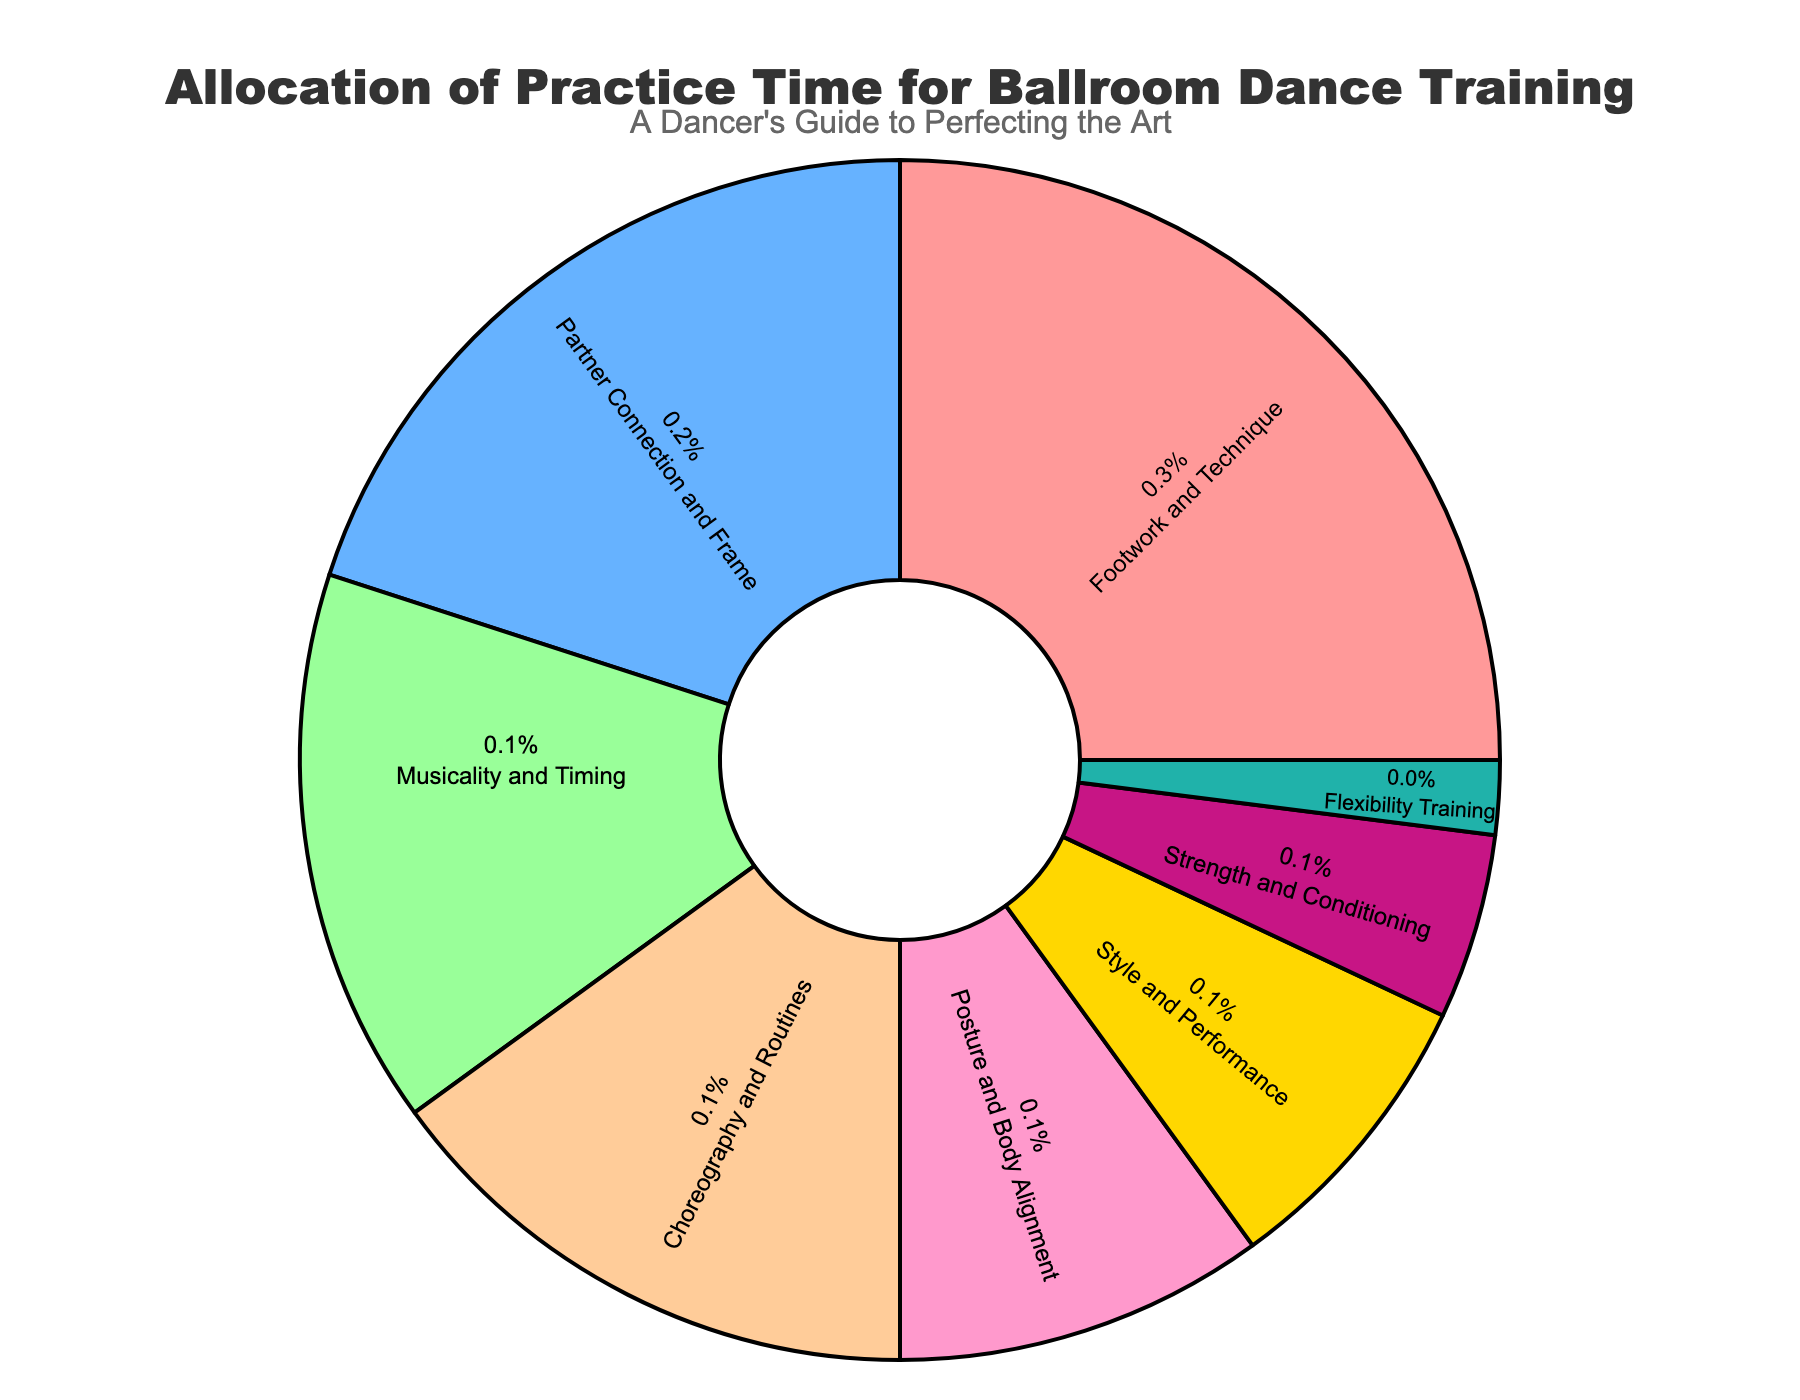what aspect of ballroom dance training takes up the largest percentage? The aspect with the largest percentage can be identified by looking at the slice with the biggest size in the pie chart, which is labeled with its percentage and aspect name. The largest slice is labeled "Footwork and Technique" with 25%.
Answer: Footwork and Technique Which aspects have an equal allocation of practice time? To find equal allocations, look for slices with the same percentage label. The aspects "Musicality and Timing" and "Choreography and Routines" both have a 15% allocation.
Answer: Musicality and Timing, Choreography and Routines How much more practice time is allocated to Footwork and Technique than to Flexibility Training? To find the difference, subtract the percentage allocated to Flexibility Training from Footwork and Technique: 25% - 2% = 23%.
Answer: 23% What is the combined allocation percentage for Partner Connection and Frame and Posture and Body Alignment? To find the combined allocation, sum the percentages for both aspects: 20% (Partner Connection and Frame) + 10% (Posture and Body Alignment) = 30%.
Answer: 30% Which aspect is allocated exactly half the percentage of Partner Connection and Frame? Half of the allocation for Partner Connection and Frame (20%) is 10%. The aspect with 10% allocation is Posture and Body Alignment.
Answer: Posture and Body Alignment Which aspect has a smaller allocation than both Style and Performance and Strength and Conditioning? Style and Performance has 8%, and Strength and Conditioning has 5%. Flexibility Training, which has 2%, is smaller than both.
Answer: Flexibility Training What is the total allocation percentage for aspects related to physical conditioning and flexibility? Sum the percentages for Strength and Conditioning and Flexibility Training: 5% (Strength and Conditioning) + 2% (Flexibility Training) = 7%.
Answer: 7% By what percentage does Footwork and Technique exceed Style and Performance? Subtract the percentage for Style and Performance from Footwork and Technique: 25% - 8% = 17%.
Answer: 17% Which aspect has been allocated a percentage that falls between the allocations of Style and Performance and Posture and Body Alignment? The percentage that falls between 8% (Style and Performance) and 10% (Posture and Body Alignment) is 9%, but no aspect has this precise allocation. Therefore, there isn't any aspect fitting this requirement exactly.
Answer: None 